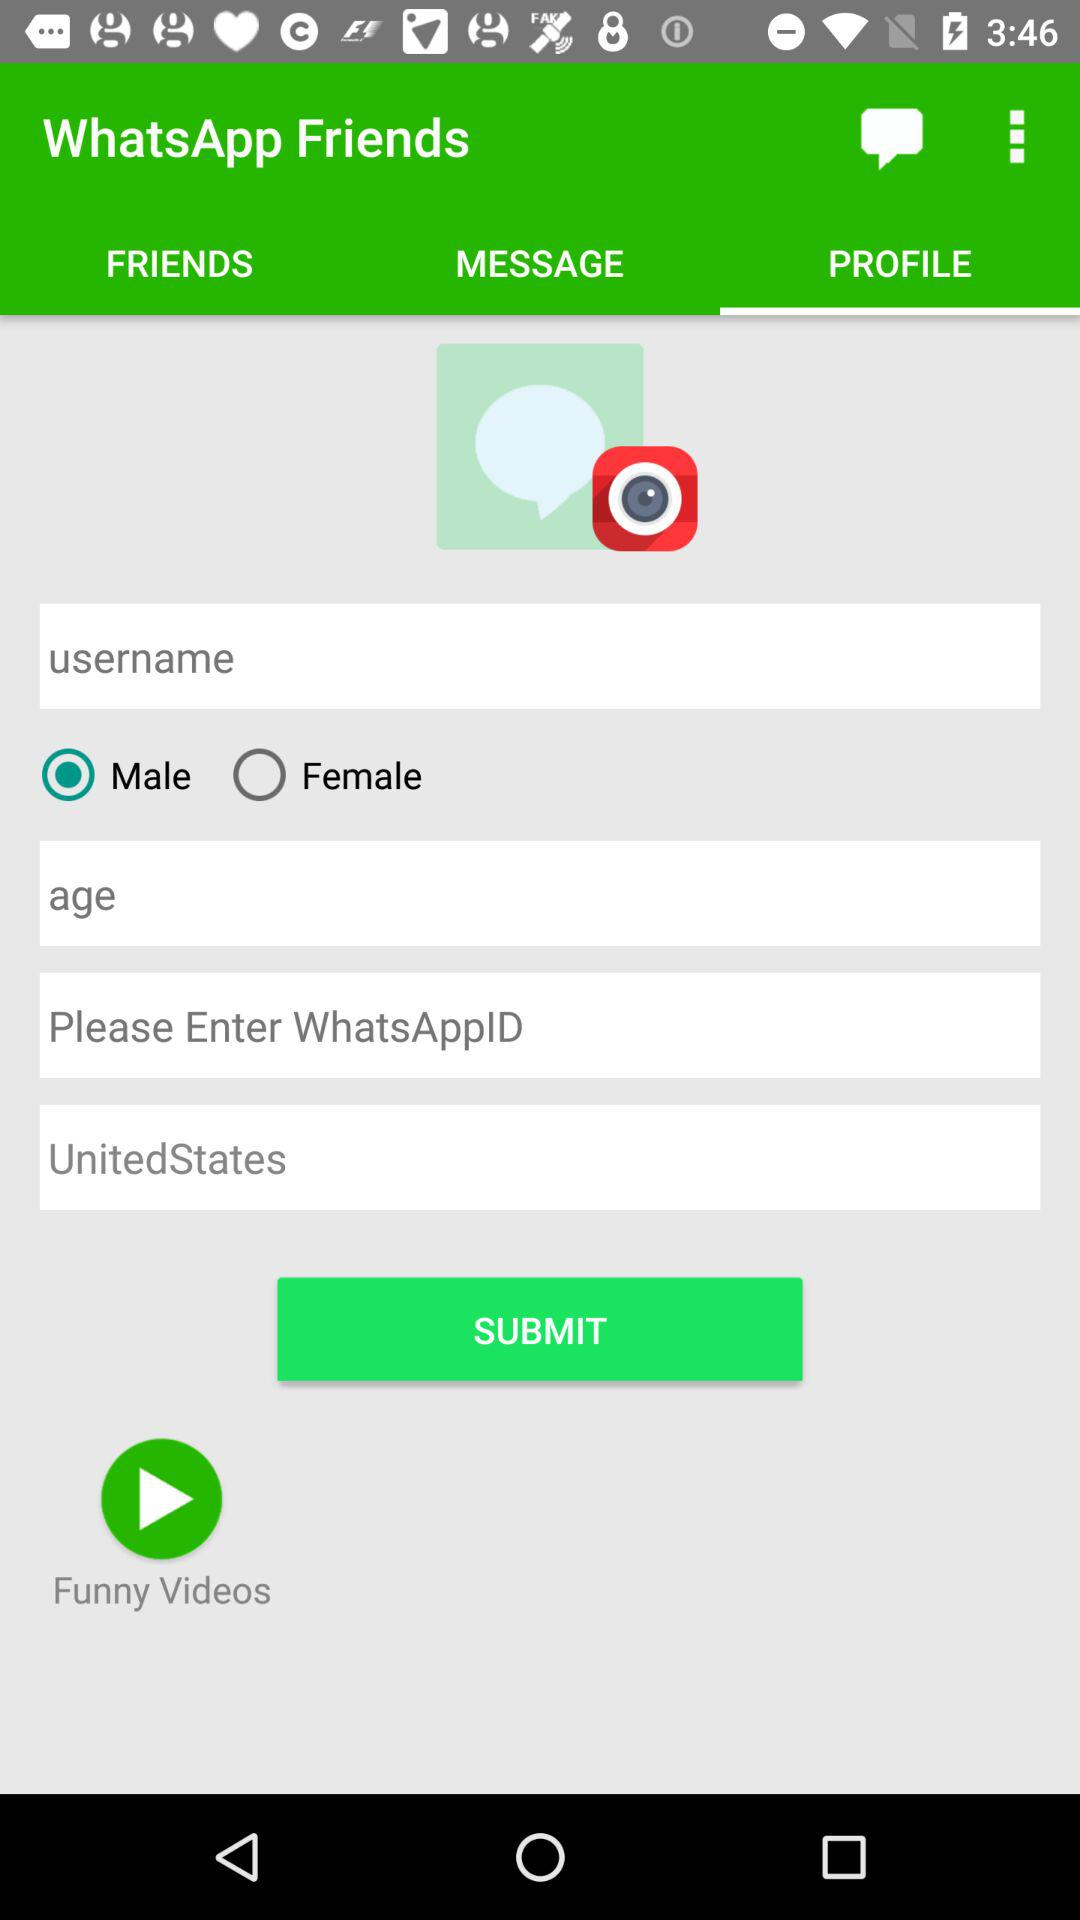Which option in "WhatsApp Friends" is selected? The selected options are "PROFILE" and "Male". 